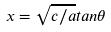<formula> <loc_0><loc_0><loc_500><loc_500>x = \sqrt { c / a } t a n \theta</formula> 